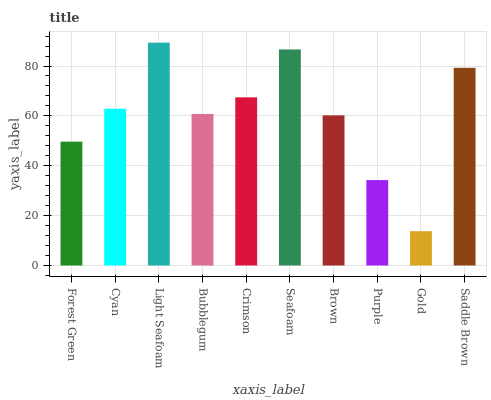Is Cyan the minimum?
Answer yes or no. No. Is Cyan the maximum?
Answer yes or no. No. Is Cyan greater than Forest Green?
Answer yes or no. Yes. Is Forest Green less than Cyan?
Answer yes or no. Yes. Is Forest Green greater than Cyan?
Answer yes or no. No. Is Cyan less than Forest Green?
Answer yes or no. No. Is Cyan the high median?
Answer yes or no. Yes. Is Bubblegum the low median?
Answer yes or no. Yes. Is Purple the high median?
Answer yes or no. No. Is Brown the low median?
Answer yes or no. No. 